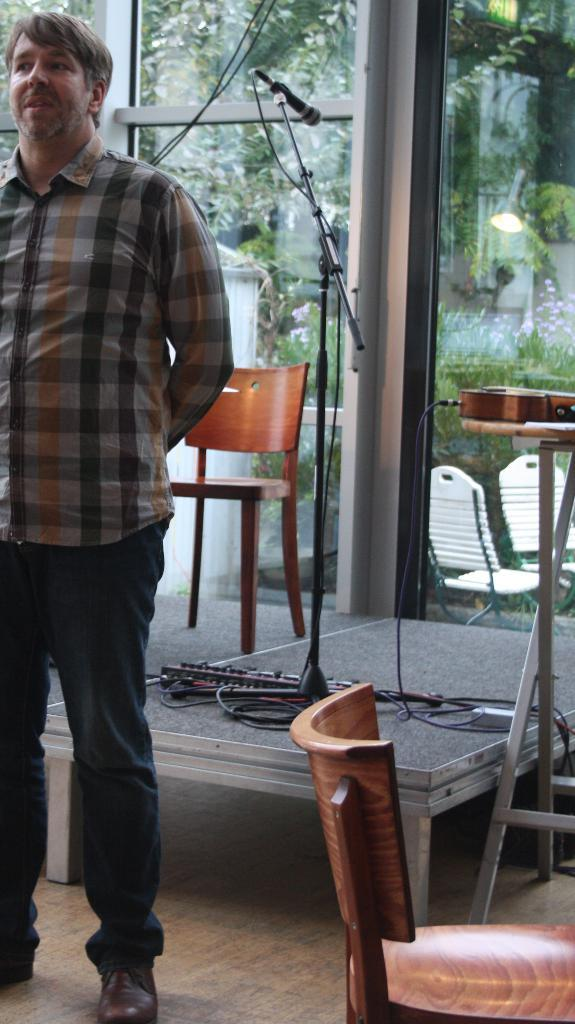What is the main subject in the image? There is a man standing in the image. How many chairs are visible in the image? There are 2 chairs in the image. What object is associated with speaking or performing in the image? There is a mic in the image. What can be seen in the background of the image? There is a window and many plants in the background of the image. Are there any additional chairs visible in the background? Yes, there are additional chairs in the background of the image. What type of pest can be seen crawling on the man's shoulder in the image? There is no pest visible on the man's shoulder in the image. What decision is the man making in the image? The image does not provide any information about a decision being made by the man. 